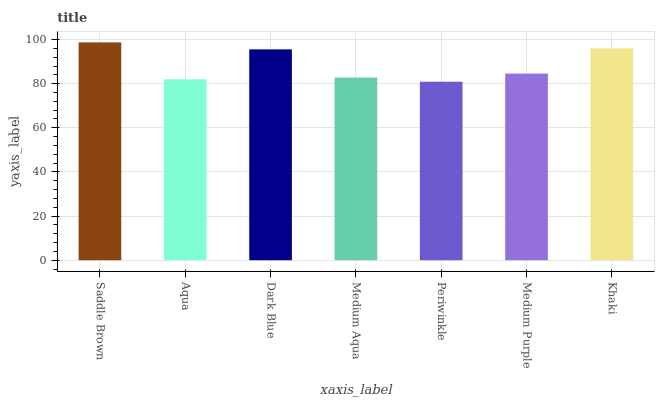Is Periwinkle the minimum?
Answer yes or no. Yes. Is Saddle Brown the maximum?
Answer yes or no. Yes. Is Aqua the minimum?
Answer yes or no. No. Is Aqua the maximum?
Answer yes or no. No. Is Saddle Brown greater than Aqua?
Answer yes or no. Yes. Is Aqua less than Saddle Brown?
Answer yes or no. Yes. Is Aqua greater than Saddle Brown?
Answer yes or no. No. Is Saddle Brown less than Aqua?
Answer yes or no. No. Is Medium Purple the high median?
Answer yes or no. Yes. Is Medium Purple the low median?
Answer yes or no. Yes. Is Khaki the high median?
Answer yes or no. No. Is Medium Aqua the low median?
Answer yes or no. No. 